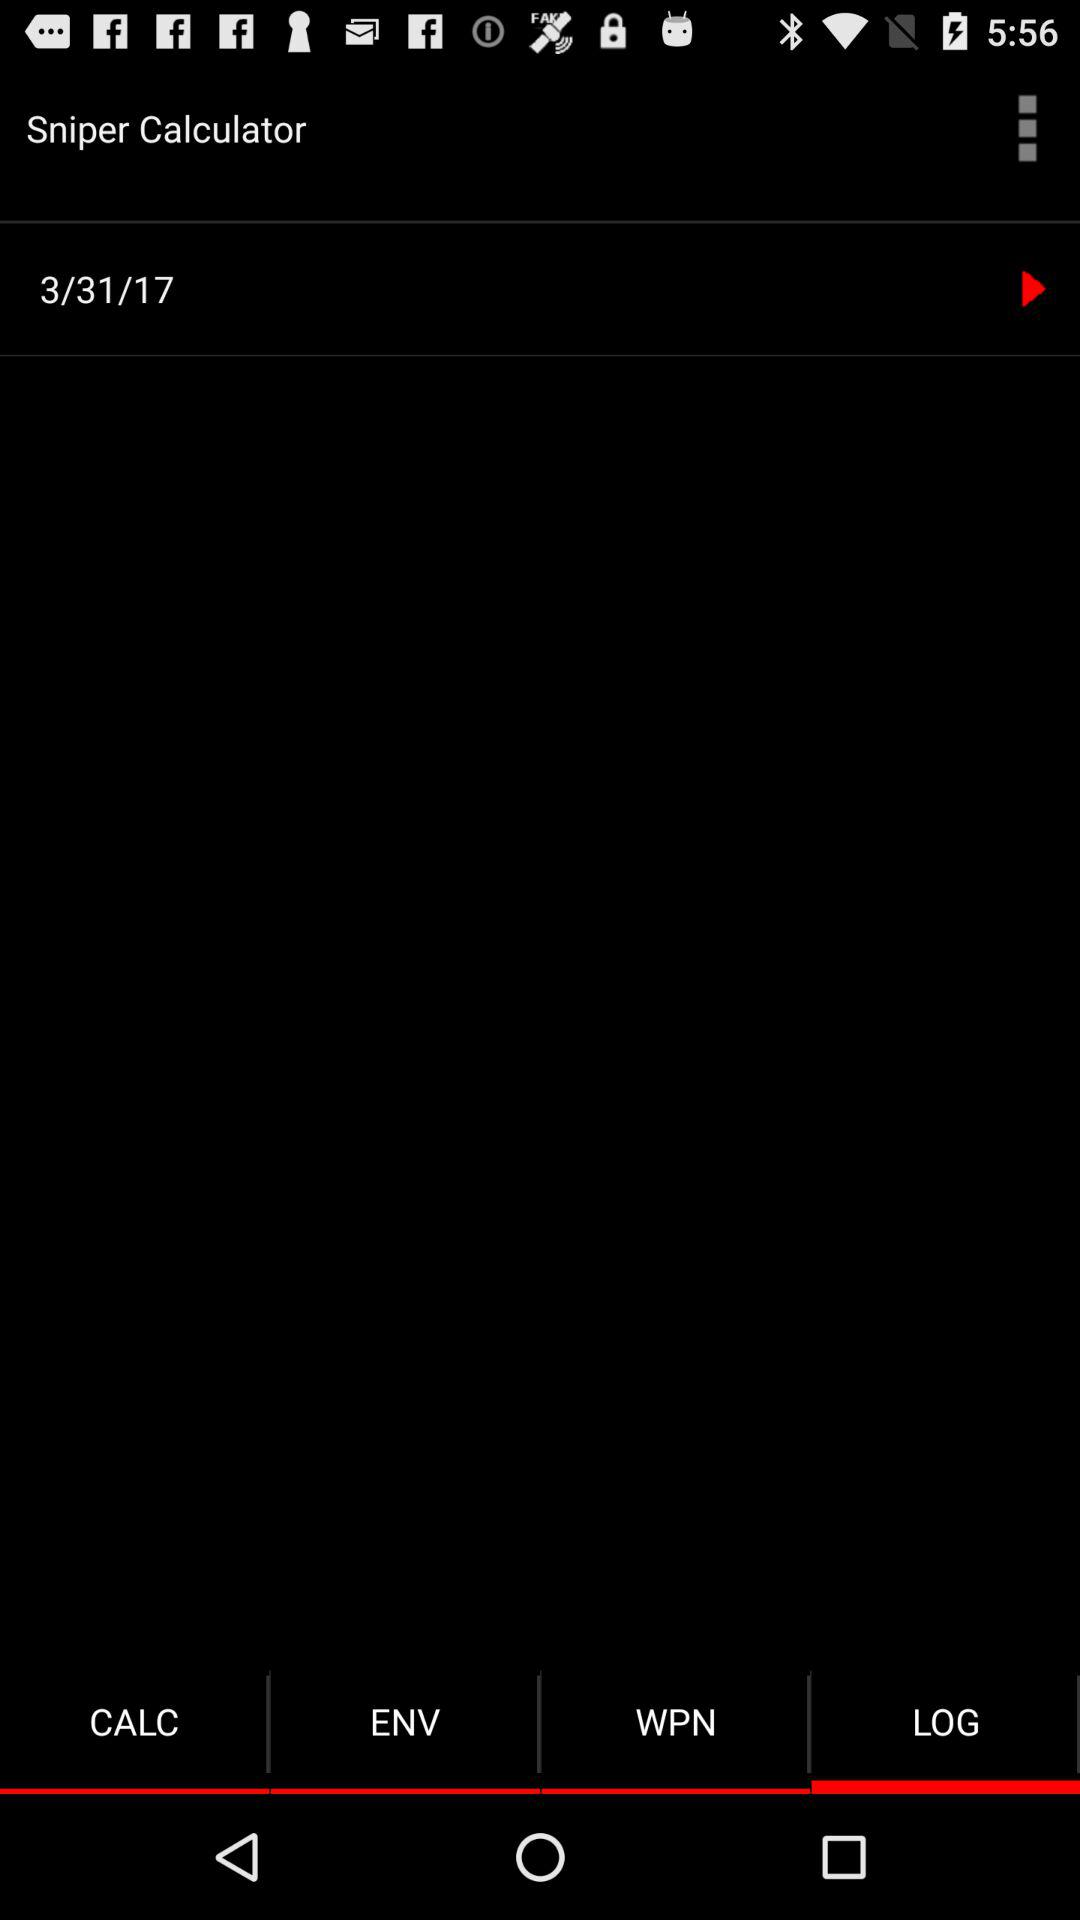How many notifications are there in "CALC"?
When the provided information is insufficient, respond with <no answer>. <no answer> 